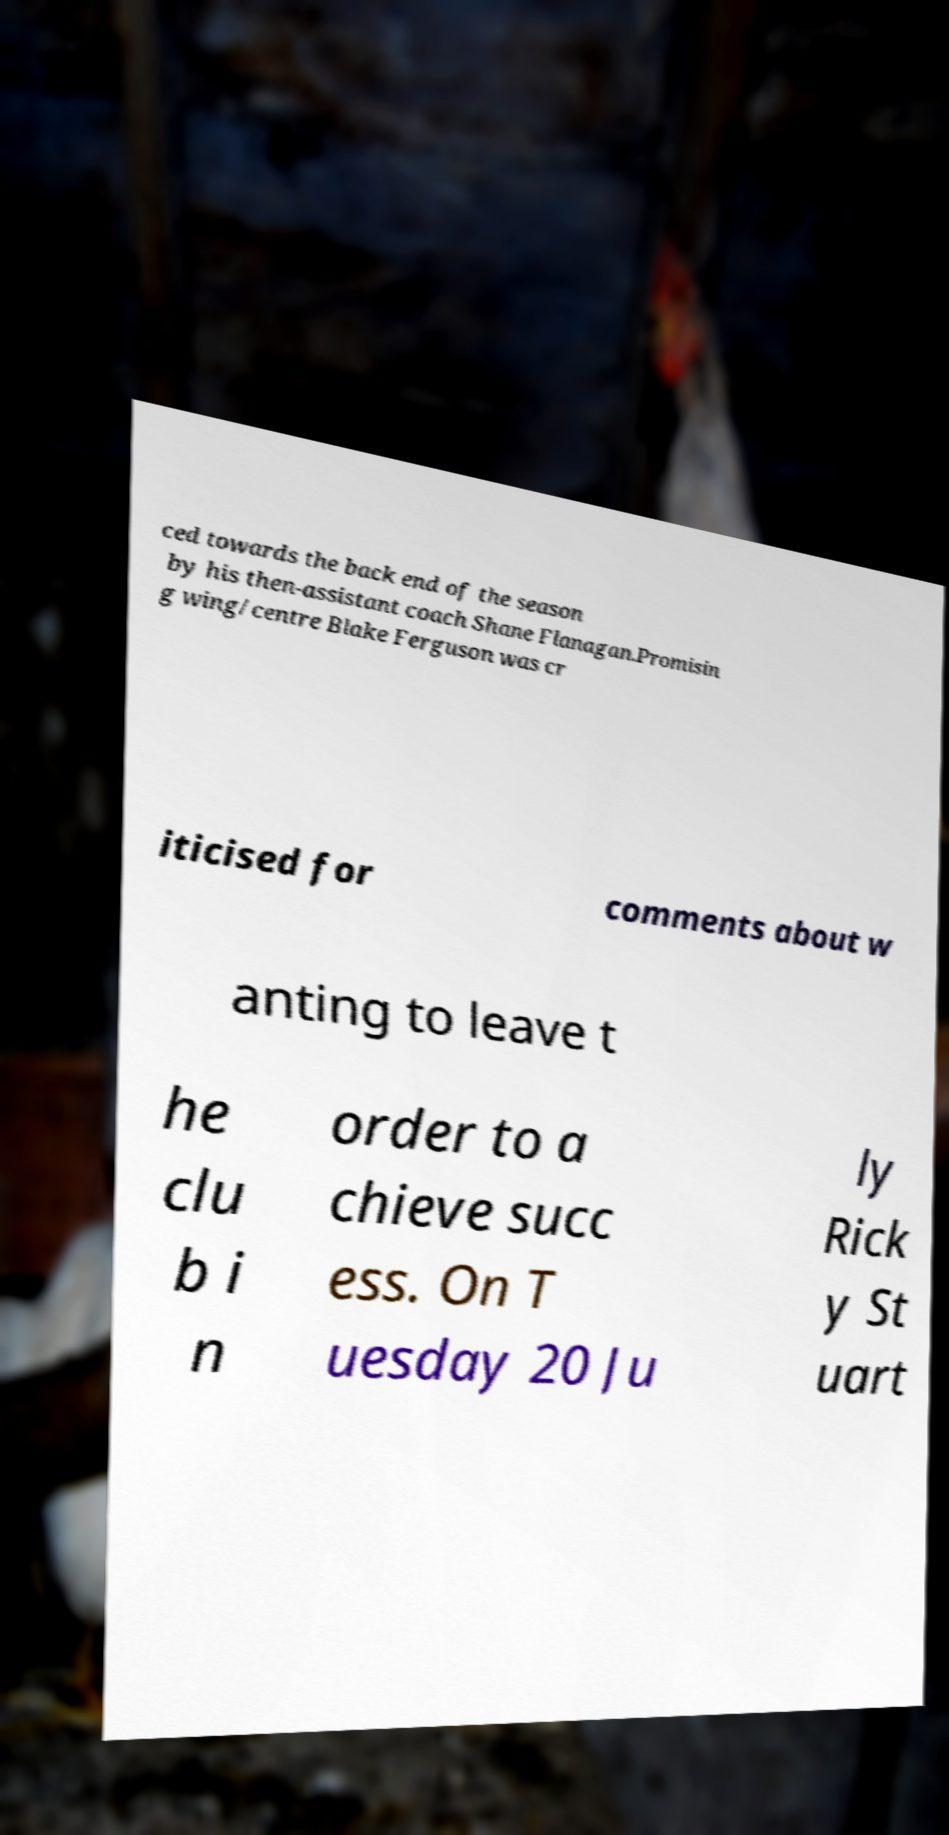What messages or text are displayed in this image? I need them in a readable, typed format. ced towards the back end of the season by his then-assistant coach Shane Flanagan.Promisin g wing/centre Blake Ferguson was cr iticised for comments about w anting to leave t he clu b i n order to a chieve succ ess. On T uesday 20 Ju ly Rick y St uart 